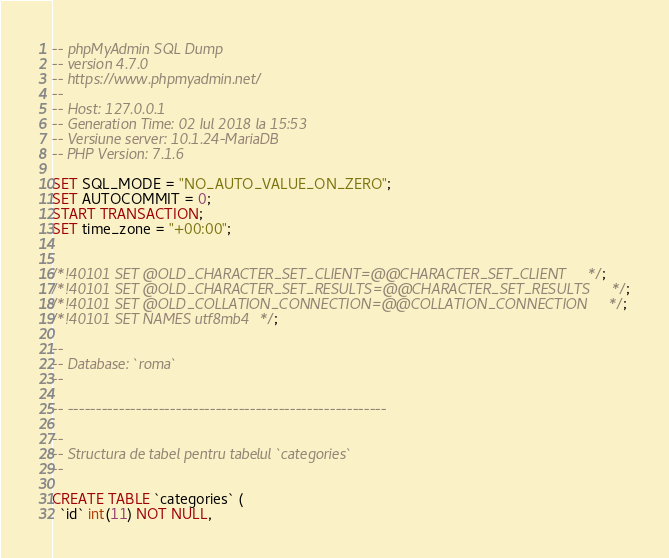<code> <loc_0><loc_0><loc_500><loc_500><_SQL_>-- phpMyAdmin SQL Dump
-- version 4.7.0
-- https://www.phpmyadmin.net/
--
-- Host: 127.0.0.1
-- Generation Time: 02 Iul 2018 la 15:53
-- Versiune server: 10.1.24-MariaDB
-- PHP Version: 7.1.6

SET SQL_MODE = "NO_AUTO_VALUE_ON_ZERO";
SET AUTOCOMMIT = 0;
START TRANSACTION;
SET time_zone = "+00:00";


/*!40101 SET @OLD_CHARACTER_SET_CLIENT=@@CHARACTER_SET_CLIENT */;
/*!40101 SET @OLD_CHARACTER_SET_RESULTS=@@CHARACTER_SET_RESULTS */;
/*!40101 SET @OLD_COLLATION_CONNECTION=@@COLLATION_CONNECTION */;
/*!40101 SET NAMES utf8mb4 */;

--
-- Database: `roma`
--

-- --------------------------------------------------------

--
-- Structura de tabel pentru tabelul `categories`
--

CREATE TABLE `categories` (
  `id` int(11) NOT NULL,</code> 